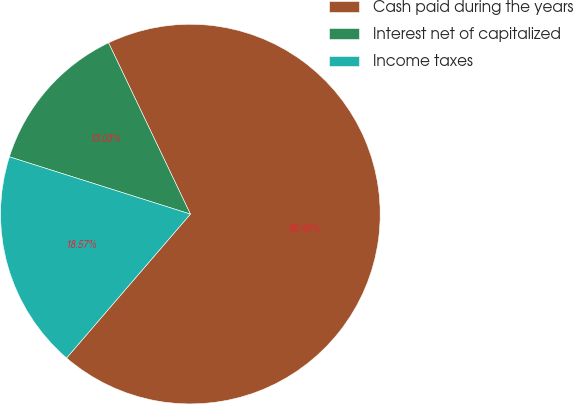Convert chart. <chart><loc_0><loc_0><loc_500><loc_500><pie_chart><fcel>Cash paid during the years<fcel>Interest net of capitalized<fcel>Income taxes<nl><fcel>68.4%<fcel>13.03%<fcel>18.57%<nl></chart> 